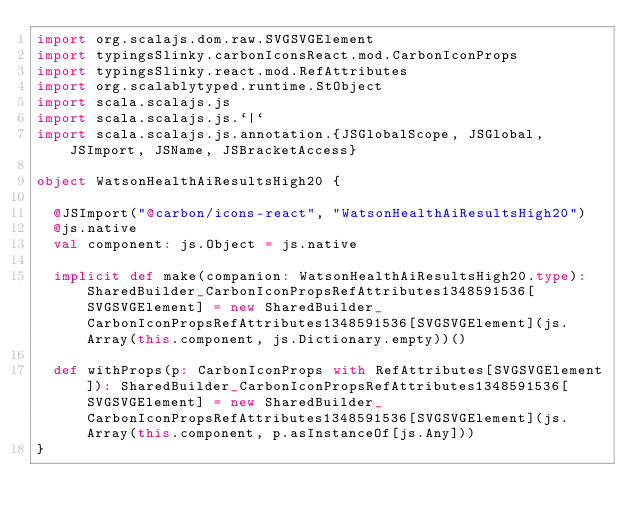<code> <loc_0><loc_0><loc_500><loc_500><_Scala_>import org.scalajs.dom.raw.SVGSVGElement
import typingsSlinky.carbonIconsReact.mod.CarbonIconProps
import typingsSlinky.react.mod.RefAttributes
import org.scalablytyped.runtime.StObject
import scala.scalajs.js
import scala.scalajs.js.`|`
import scala.scalajs.js.annotation.{JSGlobalScope, JSGlobal, JSImport, JSName, JSBracketAccess}

object WatsonHealthAiResultsHigh20 {
  
  @JSImport("@carbon/icons-react", "WatsonHealthAiResultsHigh20")
  @js.native
  val component: js.Object = js.native
  
  implicit def make(companion: WatsonHealthAiResultsHigh20.type): SharedBuilder_CarbonIconPropsRefAttributes1348591536[SVGSVGElement] = new SharedBuilder_CarbonIconPropsRefAttributes1348591536[SVGSVGElement](js.Array(this.component, js.Dictionary.empty))()
  
  def withProps(p: CarbonIconProps with RefAttributes[SVGSVGElement]): SharedBuilder_CarbonIconPropsRefAttributes1348591536[SVGSVGElement] = new SharedBuilder_CarbonIconPropsRefAttributes1348591536[SVGSVGElement](js.Array(this.component, p.asInstanceOf[js.Any]))
}
</code> 